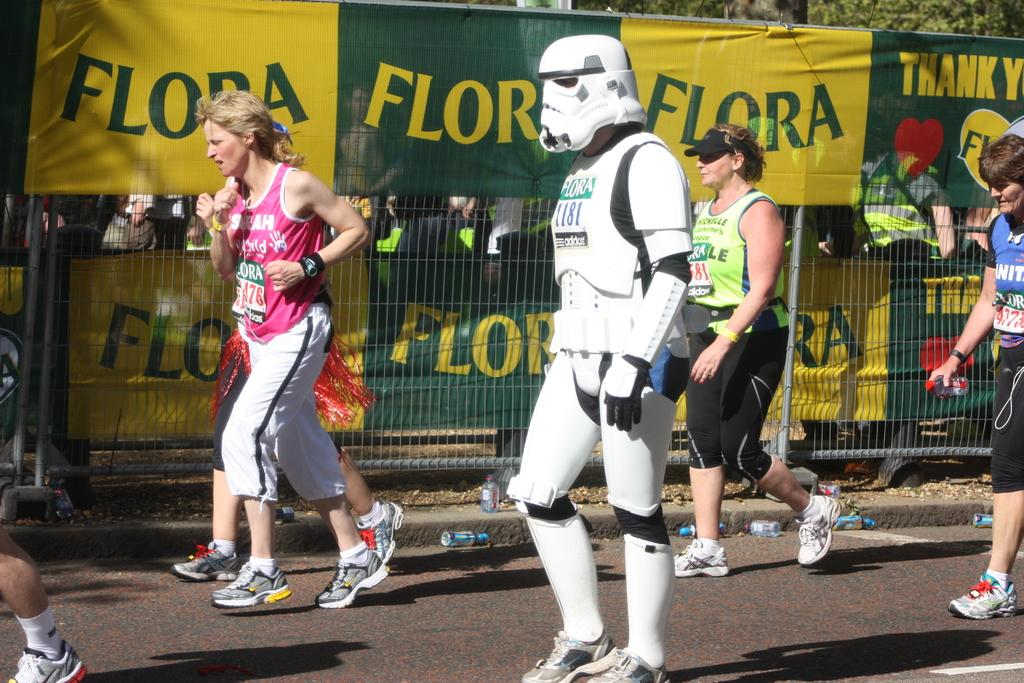<image>
Present a compact description of the photo's key features. A person in a storm trooper costume and other various runners run in front of several banners that say Flora. 